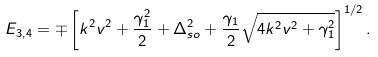Convert formula to latex. <formula><loc_0><loc_0><loc_500><loc_500>E _ { 3 , 4 } = \mp \left [ k ^ { 2 } v ^ { 2 } + \frac { \gamma _ { 1 } ^ { 2 } } { 2 } + \Delta ^ { 2 } _ { s o } + \frac { \gamma _ { 1 } } { 2 } \sqrt { 4 k ^ { 2 } v ^ { 2 } + \gamma _ { 1 } ^ { 2 } } \right ] ^ { 1 / 2 } .</formula> 